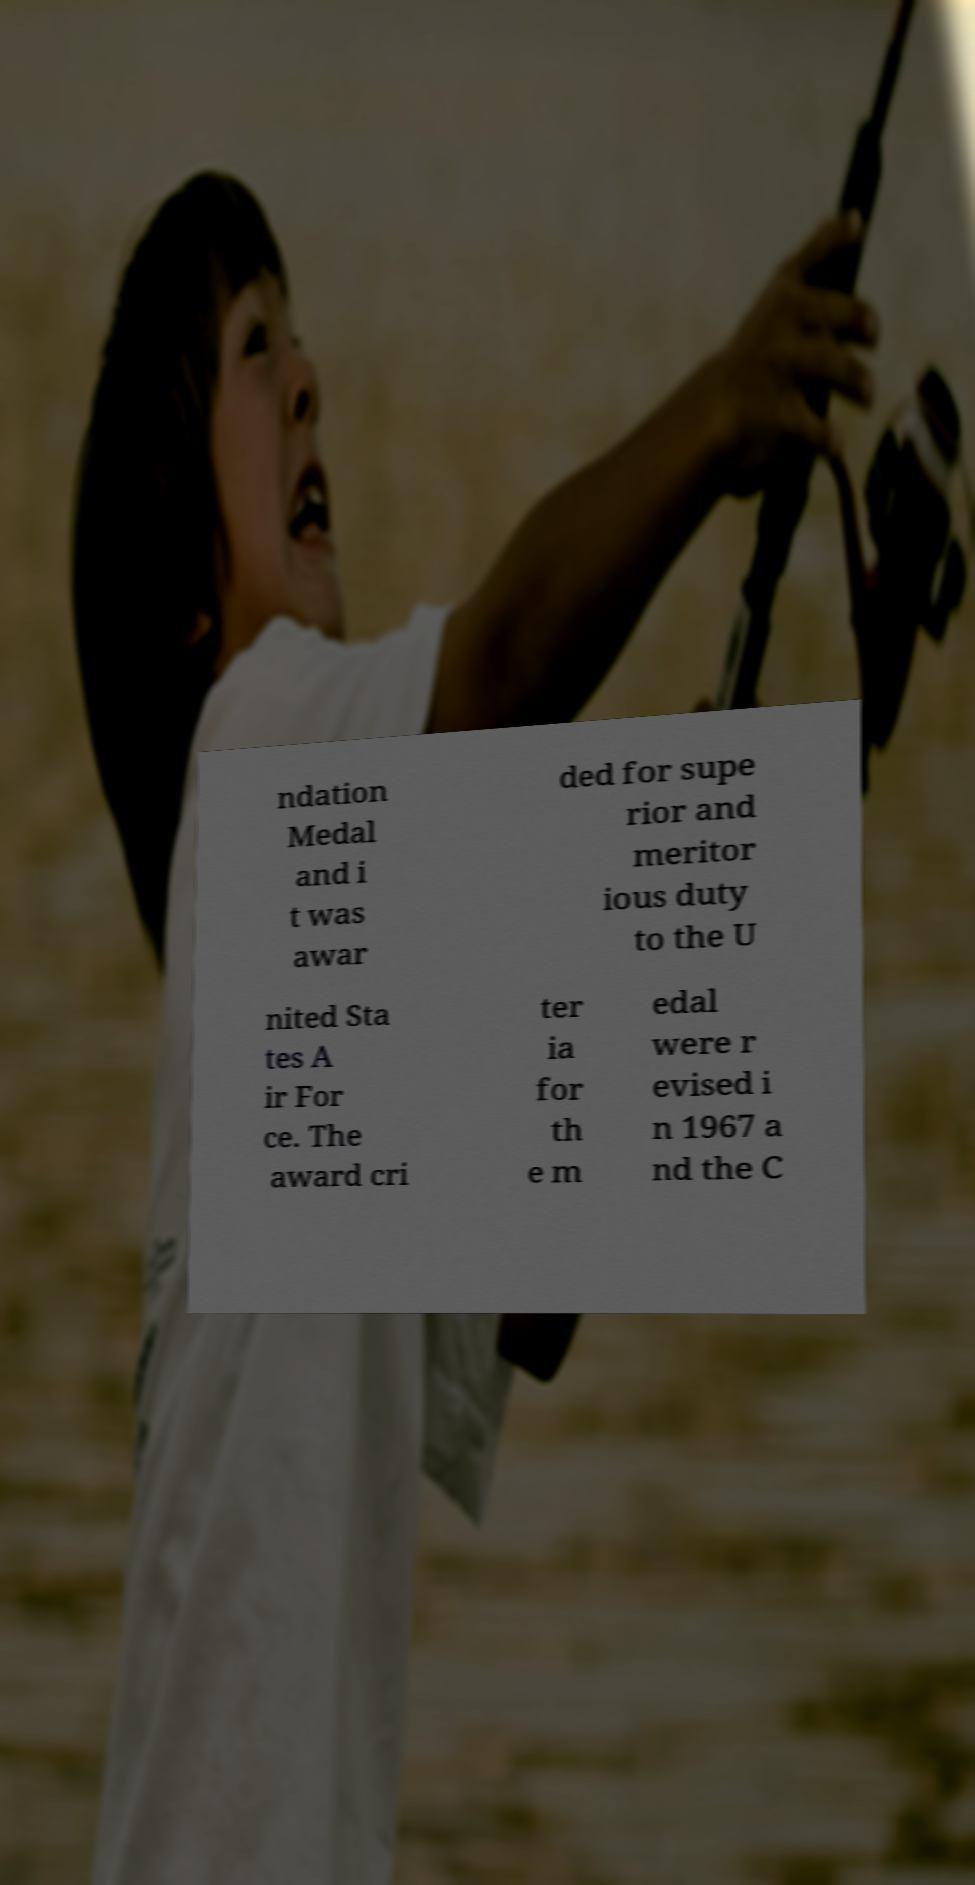For documentation purposes, I need the text within this image transcribed. Could you provide that? ndation Medal and i t was awar ded for supe rior and meritor ious duty to the U nited Sta tes A ir For ce. The award cri ter ia for th e m edal were r evised i n 1967 a nd the C 